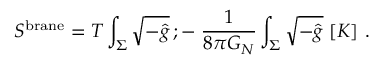Convert formula to latex. <formula><loc_0><loc_0><loc_500><loc_500>S ^ { b r a n e } = T \int _ { \Sigma } \sqrt { - \hat { g } } \, ; - \, { \frac { 1 } { 8 \pi G _ { N } } } \int _ { \Sigma } \sqrt { - \hat { g } } \, [ K ] \ .</formula> 